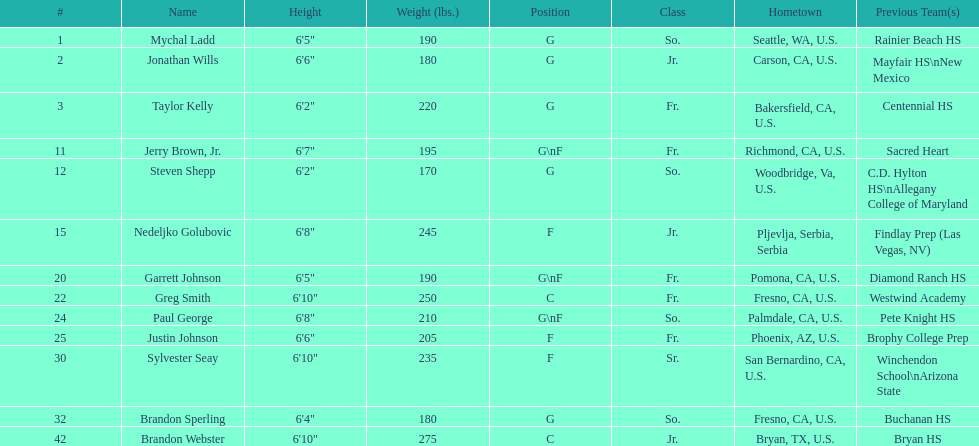Following nedelijko golubovic, which player has the next greatest weight? Sylvester Seay. 